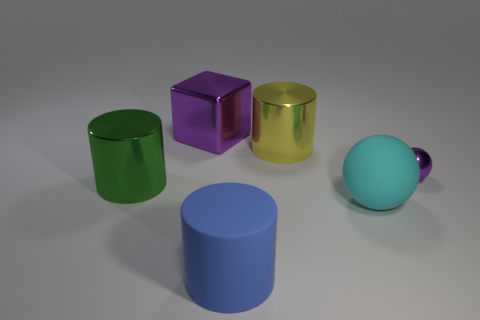Are there any other things that have the same material as the big sphere?
Your answer should be compact. Yes. Does the yellow metallic cylinder that is on the right side of the blue cylinder have the same size as the matte object on the left side of the rubber sphere?
Ensure brevity in your answer.  Yes. There is a object that is both left of the blue cylinder and behind the tiny thing; what is its material?
Offer a terse response. Metal. Is there anything else that has the same color as the large rubber sphere?
Give a very brief answer. No. Is the number of big purple cubes that are in front of the big blue thing less than the number of large purple metallic cylinders?
Make the answer very short. No. Are there more tiny matte blocks than large objects?
Give a very brief answer. No. There is a purple object that is to the left of the big cylinder in front of the big green metal thing; are there any big cylinders that are to the right of it?
Make the answer very short. Yes. How many other things are the same size as the cyan matte ball?
Your answer should be very brief. 4. Are there any cyan spheres behind the green metal object?
Your response must be concise. No. Do the big metallic cube and the big metallic cylinder that is behind the large green cylinder have the same color?
Ensure brevity in your answer.  No. 